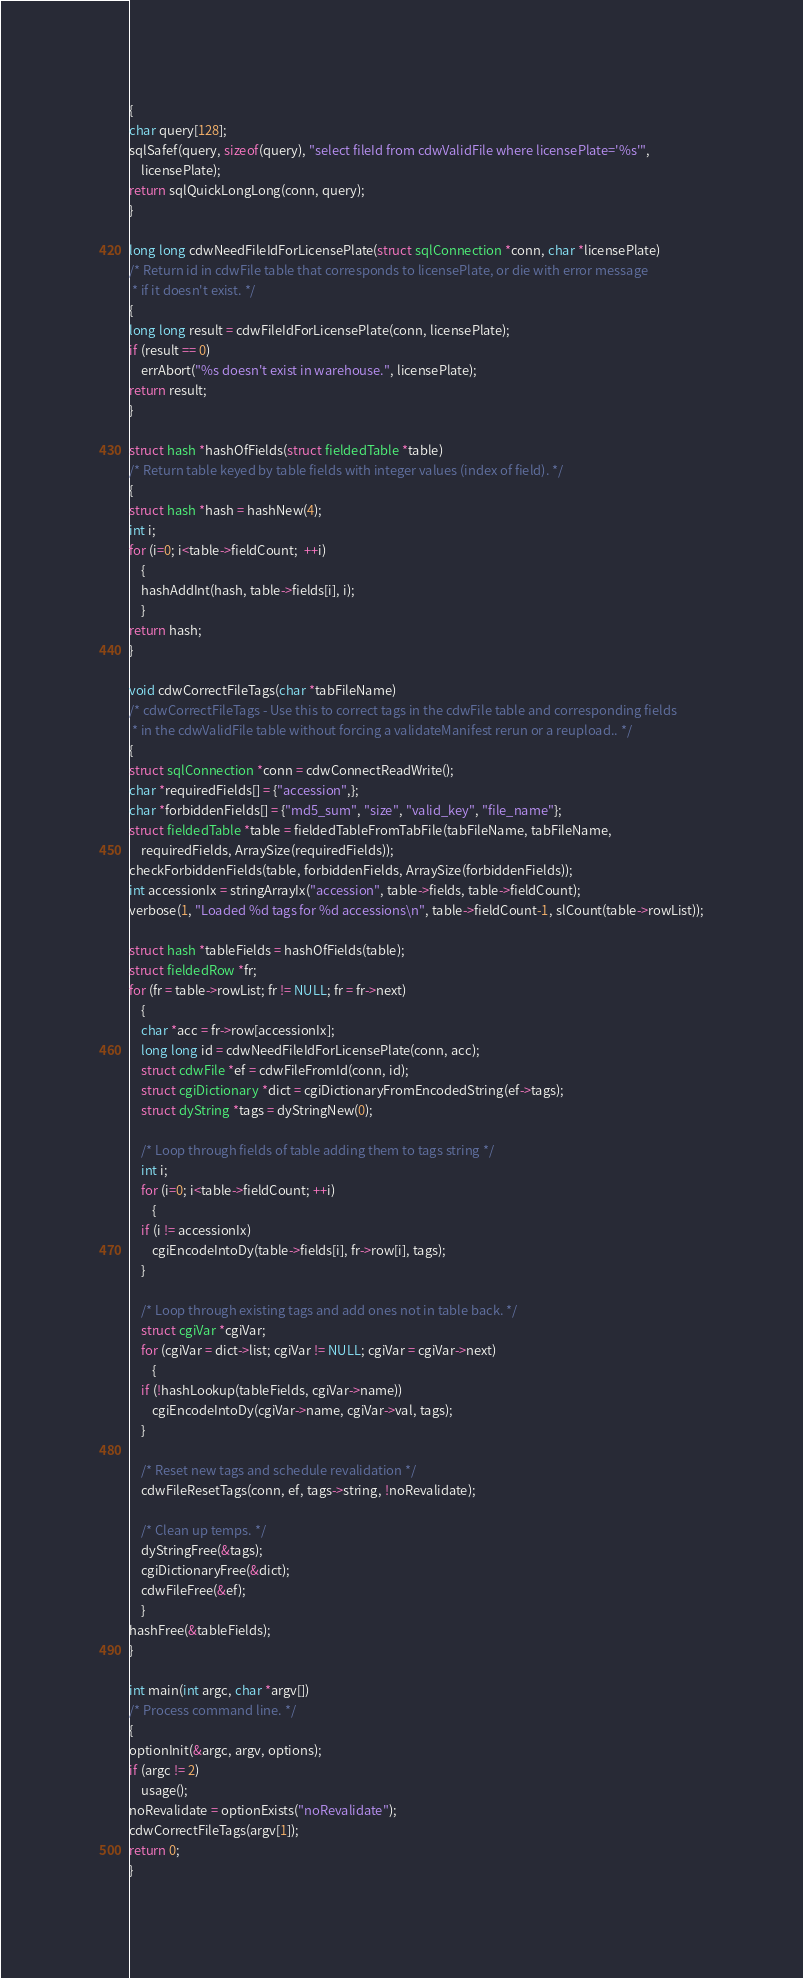Convert code to text. <code><loc_0><loc_0><loc_500><loc_500><_C_>{
char query[128];
sqlSafef(query, sizeof(query), "select fileId from cdwValidFile where licensePlate='%s'", 
    licensePlate);
return sqlQuickLongLong(conn, query);
}

long long cdwNeedFileIdForLicensePlate(struct sqlConnection *conn, char *licensePlate)
/* Return id in cdwFile table that corresponds to licensePlate, or die with error message
 * if it doesn't exist. */
{
long long result = cdwFileIdForLicensePlate(conn, licensePlate);
if (result == 0)
    errAbort("%s doesn't exist in warehouse.", licensePlate);
return result;
}

struct hash *hashOfFields(struct fieldedTable *table)
/* Return table keyed by table fields with integer values (index of field). */
{
struct hash *hash = hashNew(4);
int i;
for (i=0; i<table->fieldCount;  ++i)
    {
    hashAddInt(hash, table->fields[i], i);
    }
return hash;
}

void cdwCorrectFileTags(char *tabFileName)
/* cdwCorrectFileTags - Use this to correct tags in the cdwFile table and corresponding fields 
 * in the cdwValidFile table without forcing a validateManifest rerun or a reupload.. */
{
struct sqlConnection *conn = cdwConnectReadWrite();
char *requiredFields[] = {"accession",};
char *forbiddenFields[] = {"md5_sum", "size", "valid_key", "file_name"};
struct fieldedTable *table = fieldedTableFromTabFile(tabFileName, tabFileName,
	requiredFields, ArraySize(requiredFields));
checkForbiddenFields(table, forbiddenFields, ArraySize(forbiddenFields));
int accessionIx = stringArrayIx("accession", table->fields, table->fieldCount);
verbose(1, "Loaded %d tags for %d accessions\n", table->fieldCount-1, slCount(table->rowList));

struct hash *tableFields = hashOfFields(table);
struct fieldedRow *fr;
for (fr = table->rowList; fr != NULL; fr = fr->next)
    {
    char *acc = fr->row[accessionIx];
    long long id = cdwNeedFileIdForLicensePlate(conn, acc);
    struct cdwFile *ef = cdwFileFromId(conn, id);
    struct cgiDictionary *dict = cgiDictionaryFromEncodedString(ef->tags);
    struct dyString *tags = dyStringNew(0);

    /* Loop through fields of table adding them to tags string */
    int i;
    for (i=0; i<table->fieldCount; ++i)
        {
	if (i != accessionIx)
	    cgiEncodeIntoDy(table->fields[i], fr->row[i], tags);
	}

    /* Loop through existing tags and add ones not in table back. */
    struct cgiVar *cgiVar;
    for (cgiVar = dict->list; cgiVar != NULL; cgiVar = cgiVar->next)
        {
	if (!hashLookup(tableFields, cgiVar->name))
	    cgiEncodeIntoDy(cgiVar->name, cgiVar->val, tags);
	}

    /* Reset new tags and schedule revalidation */
    cdwFileResetTags(conn, ef, tags->string, !noRevalidate);

    /* Clean up temps. */
    dyStringFree(&tags);
    cgiDictionaryFree(&dict);
    cdwFileFree(&ef);
    }
hashFree(&tableFields);
}

int main(int argc, char *argv[])
/* Process command line. */
{
optionInit(&argc, argv, options);
if (argc != 2)
    usage();
noRevalidate = optionExists("noRevalidate");
cdwCorrectFileTags(argv[1]);
return 0;
}
</code> 